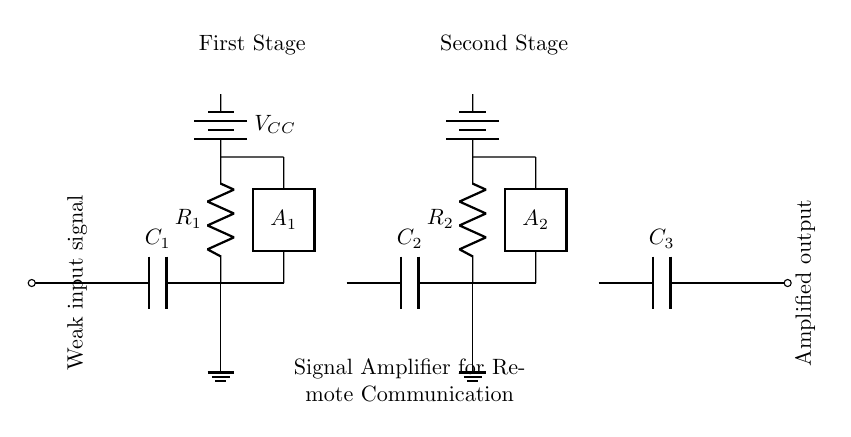What is the type of the signal being amplified? The diagram indicates that a "Weak input signal" is used, which is specified at the input.
Answer: Weak input signal What is the function of capacitor C1? Capacitor C1 is connected in series with the weak input signal and helps to block any DC components while allowing AC signals to pass for amplification.
Answer: Coupling What are the two stages of amplification labeled as? The diagram clearly labels the two stages as "First Stage" and "Second Stage," reflecting the two separate amplification processes in the circuit.
Answer: First Stage and Second Stage How many amplifiers are present in the circuit? The circuit contains two amplifiers, labeled A1 and A2, as indicated in the diagram.
Answer: Two What is the purpose of the capacitors in this circuit? The capacitors (C1, C2, and C3) serve as coupling components to separate the DC voltage levels and allow only the AC signals to pass through, essential for amplifying the communication signal without distortion.
Answer: Coupling What is the power supply voltage denoted in the circuit? The power supply voltage is not specified with a value in the diagram, but it is represented as VCC at the two stages of amplification.
Answer: VCC How does the signal flow through the circuit? The weak input signal enters the circuit, is passed through the first amplifier (A1), then through the second amplifier (A2) before being output as an amplified signal, showing the signal flow direction from input to output.
Answer: Input to A1 to A2 to output 